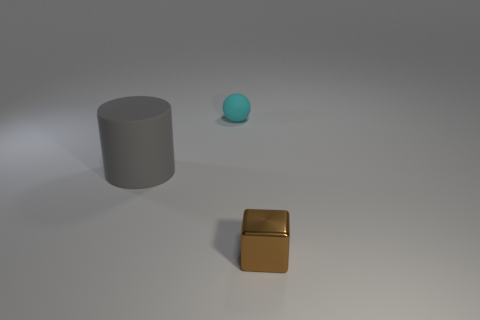Subtract all balls. How many objects are left? 2 Add 1 large matte cylinders. How many objects exist? 4 Subtract all blue spheres. How many blue cylinders are left? 0 Subtract all brown blocks. Subtract all tiny brown blocks. How many objects are left? 1 Add 3 balls. How many balls are left? 4 Add 3 big blocks. How many big blocks exist? 3 Subtract 0 yellow blocks. How many objects are left? 3 Subtract all brown balls. Subtract all yellow cubes. How many balls are left? 1 